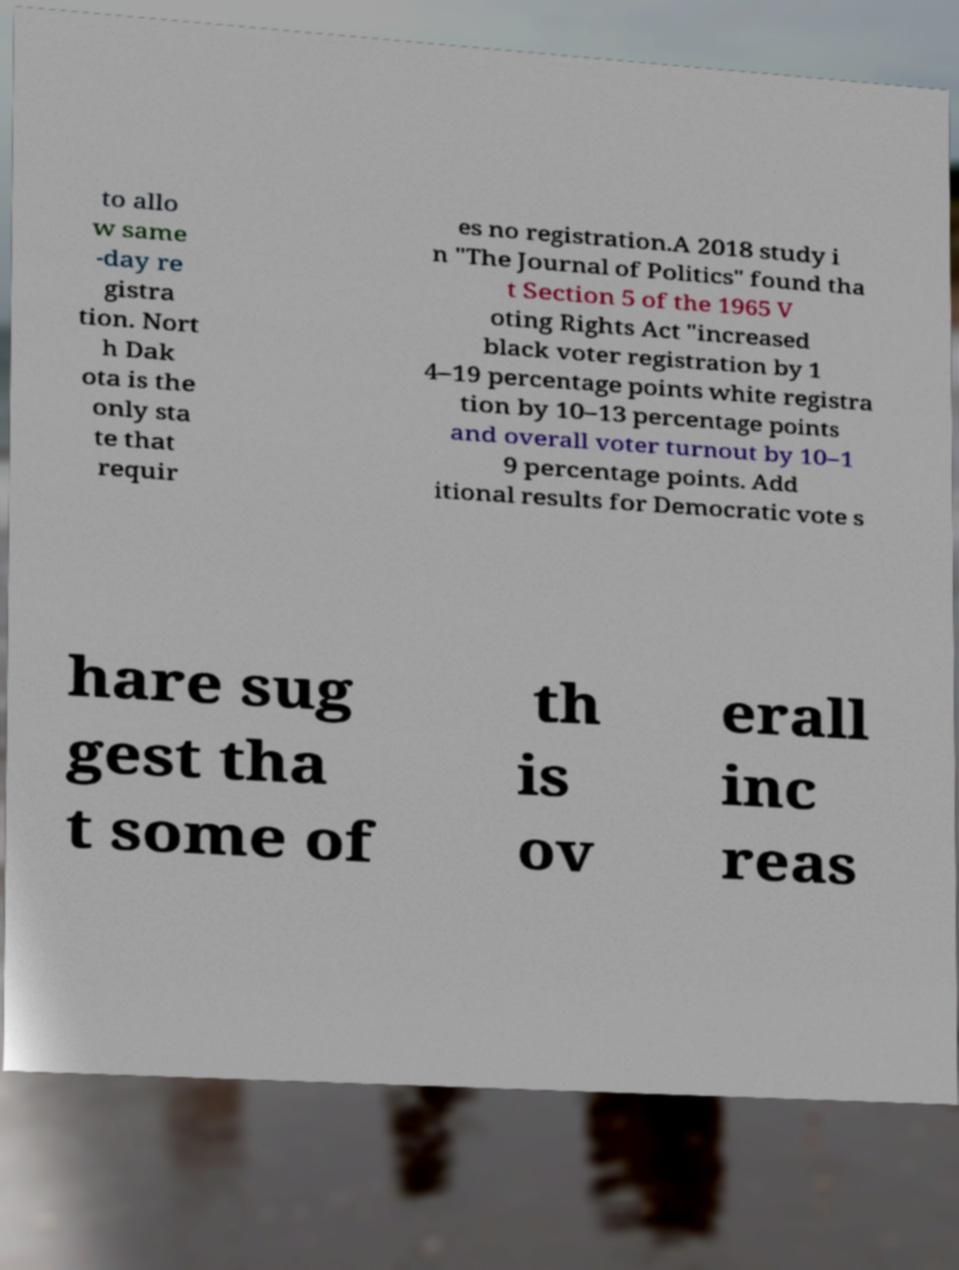For documentation purposes, I need the text within this image transcribed. Could you provide that? to allo w same -day re gistra tion. Nort h Dak ota is the only sta te that requir es no registration.A 2018 study i n "The Journal of Politics" found tha t Section 5 of the 1965 V oting Rights Act "increased black voter registration by 1 4–19 percentage points white registra tion by 10–13 percentage points and overall voter turnout by 10–1 9 percentage points. Add itional results for Democratic vote s hare sug gest tha t some of th is ov erall inc reas 